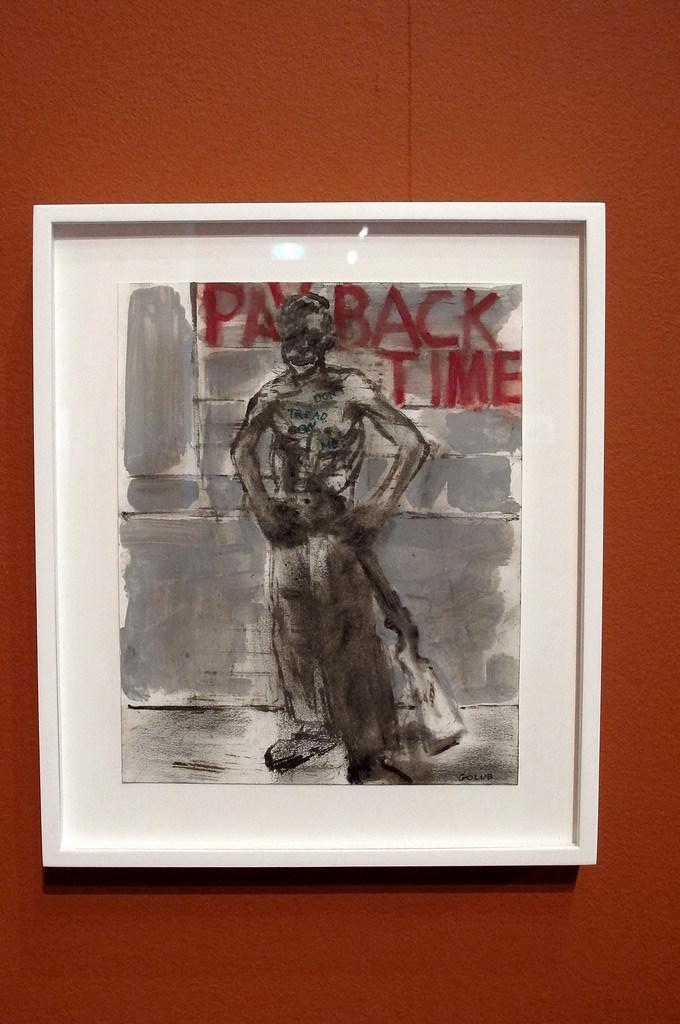<image>
Share a concise interpretation of the image provided. A slender man standing with his hands on his hips in front of a grey brick wall in front of the words in red, "payback time.' 